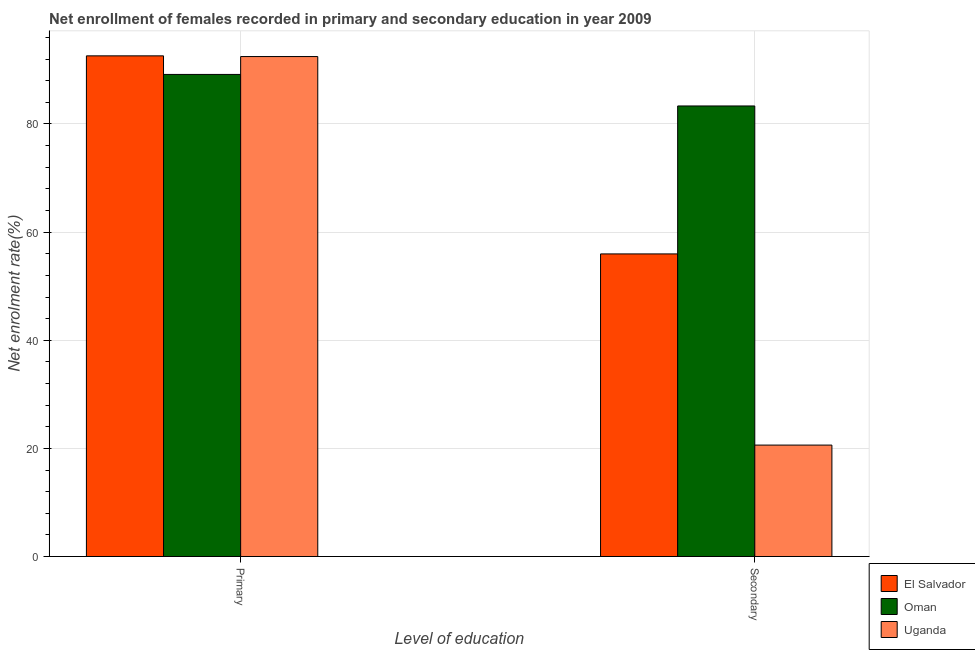Are the number of bars on each tick of the X-axis equal?
Make the answer very short. Yes. What is the label of the 1st group of bars from the left?
Your response must be concise. Primary. What is the enrollment rate in secondary education in Uganda?
Provide a succinct answer. 20.61. Across all countries, what is the maximum enrollment rate in secondary education?
Provide a succinct answer. 83.33. Across all countries, what is the minimum enrollment rate in primary education?
Make the answer very short. 89.17. In which country was the enrollment rate in primary education maximum?
Ensure brevity in your answer.  El Salvador. In which country was the enrollment rate in secondary education minimum?
Give a very brief answer. Uganda. What is the total enrollment rate in primary education in the graph?
Offer a very short reply. 274.24. What is the difference between the enrollment rate in secondary education in Uganda and that in Oman?
Ensure brevity in your answer.  -62.72. What is the difference between the enrollment rate in secondary education in Uganda and the enrollment rate in primary education in El Salvador?
Provide a short and direct response. -71.99. What is the average enrollment rate in secondary education per country?
Your response must be concise. 53.3. What is the difference between the enrollment rate in primary education and enrollment rate in secondary education in Oman?
Keep it short and to the point. 5.83. What is the ratio of the enrollment rate in primary education in El Salvador to that in Oman?
Offer a very short reply. 1.04. In how many countries, is the enrollment rate in primary education greater than the average enrollment rate in primary education taken over all countries?
Your response must be concise. 2. What does the 1st bar from the left in Primary represents?
Provide a succinct answer. El Salvador. What does the 2nd bar from the right in Secondary represents?
Provide a short and direct response. Oman. What is the difference between two consecutive major ticks on the Y-axis?
Make the answer very short. 20. Does the graph contain grids?
Offer a terse response. Yes. Where does the legend appear in the graph?
Keep it short and to the point. Bottom right. How many legend labels are there?
Your answer should be very brief. 3. How are the legend labels stacked?
Keep it short and to the point. Vertical. What is the title of the graph?
Give a very brief answer. Net enrollment of females recorded in primary and secondary education in year 2009. Does "Bermuda" appear as one of the legend labels in the graph?
Provide a short and direct response. No. What is the label or title of the X-axis?
Make the answer very short. Level of education. What is the label or title of the Y-axis?
Provide a succinct answer. Net enrolment rate(%). What is the Net enrolment rate(%) of El Salvador in Primary?
Provide a succinct answer. 92.6. What is the Net enrolment rate(%) of Oman in Primary?
Give a very brief answer. 89.17. What is the Net enrolment rate(%) of Uganda in Primary?
Provide a succinct answer. 92.47. What is the Net enrolment rate(%) in El Salvador in Secondary?
Provide a succinct answer. 55.97. What is the Net enrolment rate(%) of Oman in Secondary?
Make the answer very short. 83.33. What is the Net enrolment rate(%) of Uganda in Secondary?
Your answer should be compact. 20.61. Across all Level of education, what is the maximum Net enrolment rate(%) in El Salvador?
Offer a very short reply. 92.6. Across all Level of education, what is the maximum Net enrolment rate(%) of Oman?
Keep it short and to the point. 89.17. Across all Level of education, what is the maximum Net enrolment rate(%) of Uganda?
Keep it short and to the point. 92.47. Across all Level of education, what is the minimum Net enrolment rate(%) in El Salvador?
Your answer should be very brief. 55.97. Across all Level of education, what is the minimum Net enrolment rate(%) of Oman?
Your response must be concise. 83.33. Across all Level of education, what is the minimum Net enrolment rate(%) in Uganda?
Ensure brevity in your answer.  20.61. What is the total Net enrolment rate(%) of El Salvador in the graph?
Keep it short and to the point. 148.57. What is the total Net enrolment rate(%) of Oman in the graph?
Your answer should be compact. 172.5. What is the total Net enrolment rate(%) in Uganda in the graph?
Make the answer very short. 113.08. What is the difference between the Net enrolment rate(%) in El Salvador in Primary and that in Secondary?
Keep it short and to the point. 36.63. What is the difference between the Net enrolment rate(%) of Oman in Primary and that in Secondary?
Provide a short and direct response. 5.83. What is the difference between the Net enrolment rate(%) in Uganda in Primary and that in Secondary?
Give a very brief answer. 71.86. What is the difference between the Net enrolment rate(%) in El Salvador in Primary and the Net enrolment rate(%) in Oman in Secondary?
Provide a short and direct response. 9.27. What is the difference between the Net enrolment rate(%) in El Salvador in Primary and the Net enrolment rate(%) in Uganda in Secondary?
Make the answer very short. 71.99. What is the difference between the Net enrolment rate(%) in Oman in Primary and the Net enrolment rate(%) in Uganda in Secondary?
Offer a terse response. 68.56. What is the average Net enrolment rate(%) of El Salvador per Level of education?
Make the answer very short. 74.28. What is the average Net enrolment rate(%) of Oman per Level of education?
Offer a terse response. 86.25. What is the average Net enrolment rate(%) of Uganda per Level of education?
Offer a terse response. 56.54. What is the difference between the Net enrolment rate(%) of El Salvador and Net enrolment rate(%) of Oman in Primary?
Ensure brevity in your answer.  3.43. What is the difference between the Net enrolment rate(%) of El Salvador and Net enrolment rate(%) of Uganda in Primary?
Your answer should be very brief. 0.13. What is the difference between the Net enrolment rate(%) in Oman and Net enrolment rate(%) in Uganda in Primary?
Provide a succinct answer. -3.31. What is the difference between the Net enrolment rate(%) in El Salvador and Net enrolment rate(%) in Oman in Secondary?
Provide a succinct answer. -27.36. What is the difference between the Net enrolment rate(%) of El Salvador and Net enrolment rate(%) of Uganda in Secondary?
Make the answer very short. 35.36. What is the difference between the Net enrolment rate(%) of Oman and Net enrolment rate(%) of Uganda in Secondary?
Keep it short and to the point. 62.72. What is the ratio of the Net enrolment rate(%) of El Salvador in Primary to that in Secondary?
Provide a succinct answer. 1.65. What is the ratio of the Net enrolment rate(%) in Oman in Primary to that in Secondary?
Your response must be concise. 1.07. What is the ratio of the Net enrolment rate(%) in Uganda in Primary to that in Secondary?
Offer a terse response. 4.49. What is the difference between the highest and the second highest Net enrolment rate(%) in El Salvador?
Make the answer very short. 36.63. What is the difference between the highest and the second highest Net enrolment rate(%) in Oman?
Make the answer very short. 5.83. What is the difference between the highest and the second highest Net enrolment rate(%) of Uganda?
Offer a terse response. 71.86. What is the difference between the highest and the lowest Net enrolment rate(%) of El Salvador?
Provide a short and direct response. 36.63. What is the difference between the highest and the lowest Net enrolment rate(%) in Oman?
Provide a short and direct response. 5.83. What is the difference between the highest and the lowest Net enrolment rate(%) of Uganda?
Make the answer very short. 71.86. 